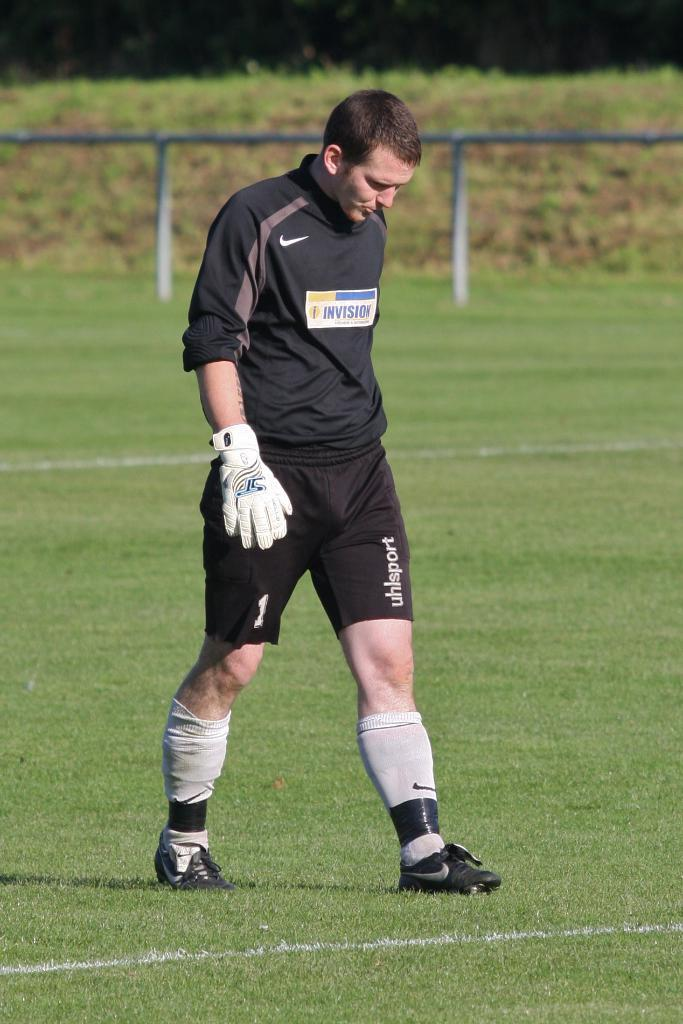What is the main subject of the image? There is a person standing in the center of the image. What is the person wearing on their hand? The person is wearing a glove. What type of surface can be seen in the background of the image? There is ground visible in the background of the image. What objects are present at the top of the image? Rods are present at the top of the image. What message of peace can be seen written on a note in the image? There is no note or message of peace present in the image. What type of town is visible in the background of the image? There is no town visible in the background of the image; only ground can be seen. 